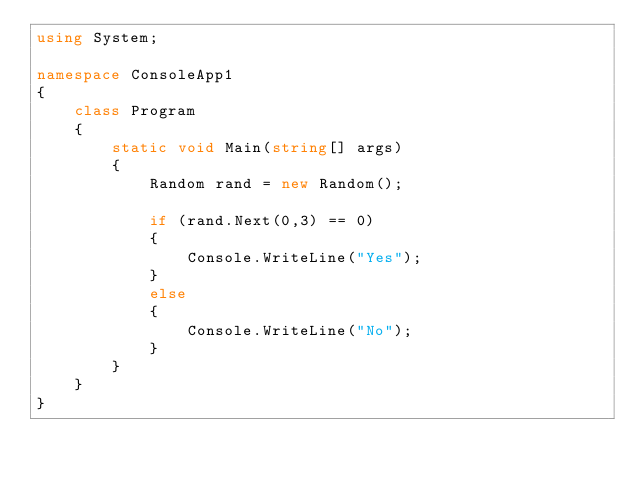<code> <loc_0><loc_0><loc_500><loc_500><_C#_>using System;

namespace ConsoleApp1
{
    class Program
    {
        static void Main(string[] args)
        {
            Random rand = new Random();

            if (rand.Next(0,3) == 0)
            {
                Console.WriteLine("Yes");
            }
            else
            {
                Console.WriteLine("No");
            }
        }
    }
}
</code> 